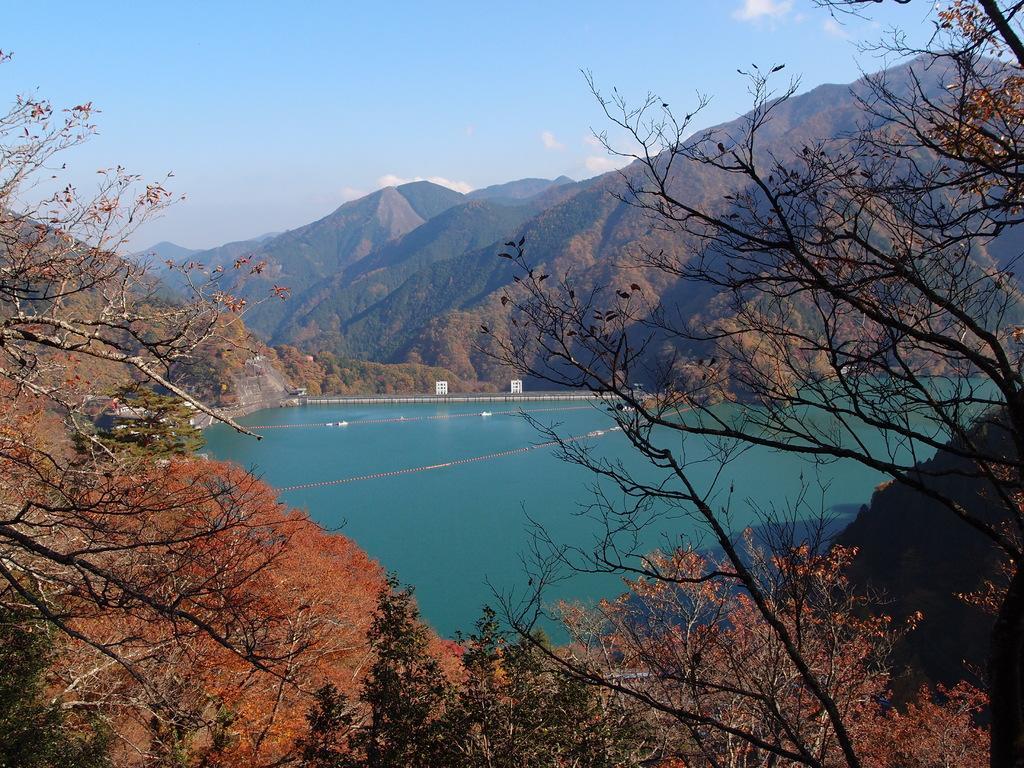In one or two sentences, can you explain what this image depicts? As we can see in the image there are trees, hills, water and a sky. 